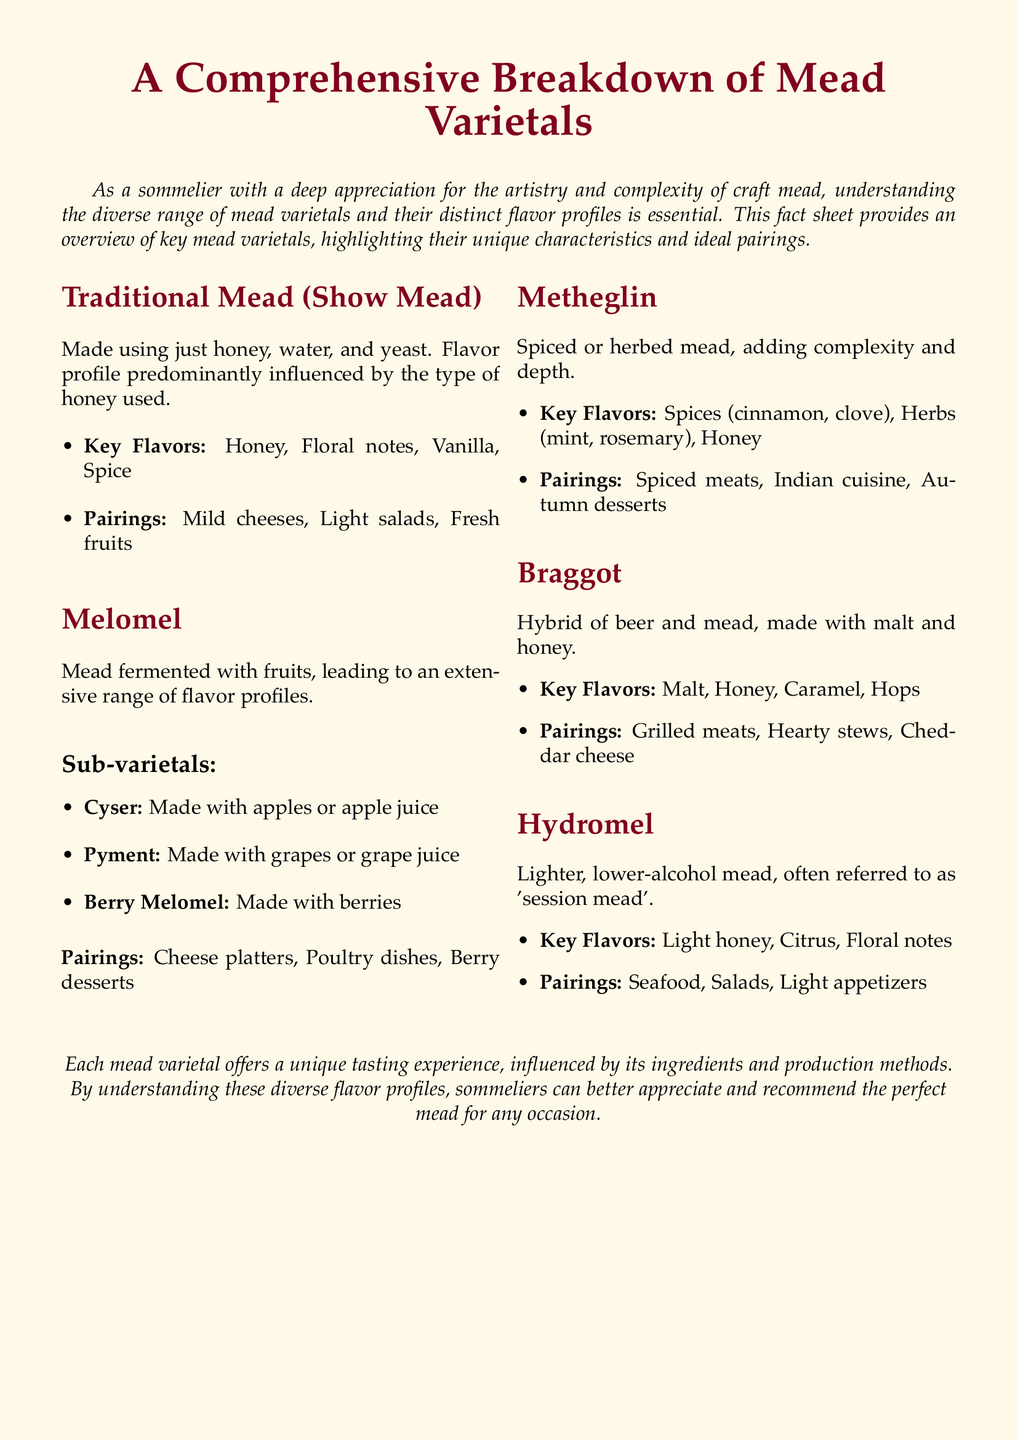What are the main ingredients of Traditional Mead? Traditional Mead is made using just honey, water, and yeast.
Answer: Honey, water, and yeast What is a key flavor profile of Metheglin? Metheglin is characterized by its spices and herbs along with honey.
Answer: Spices (cinnamon, clove), Herbs (mint, rosemary), Honey What is the pairing suggestion for Hydromel? Hydromel pairs well with specific food items as listed in the document.
Answer: Seafood, Salads, Light appetizers What type of fruit is used in a Cyser? Cyser is a type of Melomel made specifically with a certain fruit.
Answer: Apples What hybrid does Braggot represent? Braggot is a combination of beer and another beverage.
Answer: Beer and mead What distinguishes Melomel from other mead varietals? Melomel is distinct because it is fermented with fruits, leading to varied flavors.
Answer: Fermented with fruits What is the purpose of this fact sheet? The fact sheet serves to provide an overview of mead varietals and their flavor profiles.
Answer: Overview of key mead varietals How would you describe Hydromel regarding its alcohol content? Hydromel is characterized by its alcohol content compared to other meads.
Answer: Lighter, lower-alcohol What is a common pairing for Metheglin? A specific cuisine is noted as a favorable pairing for Metheglin.
Answer: Indian cuisine 